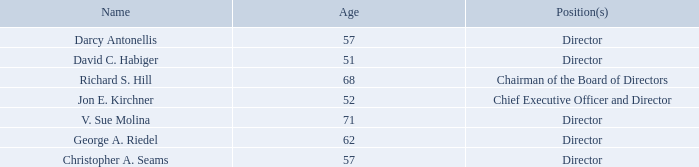Item 10. Directors, Executive Officers and Corporate Governance
Information About Our Board of Directors
Set forth below are the name, age and position of each member of our board of directors.
The following are biographical summaries of our board members.
Darcy Antonellis has served on the Board since December 2018. Since January 2014, Ms. Antonellis has been the Chief Executive Officer of Vubiquity, Inc., a wholly owned subsidiary of Amdocs Limited since February 22, 2018, the largest global provider of premium content services and technical solutions serving clients in 120 countries and in 80 languages. From June 1998 until December 2013, Ms. Antonellis held numerous positions at Warner Bros. Entertainment Inc., a Time Warner company, including President, Technical Operations and Chief Technology Officer. Ms. Antonellis has also served as a member of the Board of Directors of Cinemark Holdings, Inc. since July 7, 2015. Ms, Antonellis received a B.S. in electrical engineering from Temple University and an M.B.A. from Fordham University. The Board believes Ms. Antonellis brings her extensive expertise in executive management, operations and engineering and her in-depth understanding of content services, media and entertainment industry to her role as a member of the Board.
David C. Habiger has served on the Board since December 2016. Mr. Habiger currently serves as the Chief Executive Officer of JD Power, a privately held company. Mr. Habiger served as a director of DTS from March 2014 until its acquisition by the Company in December 2016. Mr. Habiger serves as a director of the Chicago Federal Reserve Board. He is on the SABOR (Systems Activities, Bank Operations and Risk) Committee and the Governance & HR Committee for the
Federal Reserve. Mr. Habiger served as the CEO at Textura Corporation, a soft
David C. Habiger has served on the Board since December 2016. Mr. Habiger currently serves as the Chief Executive Officer of JD Power, a privately held company. Mr. Habiger served as a director of DTS from March 2014 until its acquisition by the Company in December 2016. Mr. Habiger serves as a director of the Chicago Federal Reserve Board. He is on the SABOR (Systems Activities, Bank Operations and Risk) Committee and the Governance & HR Committee for the Federal Reserve. Mr. Habiger served as the CEO at Textura Corporation, a soft David C. Habiger has served on the Board since December 2016. Mr. Habiger currently serves as the Chief Executive Officer of JD Power, a privately held company. Mr. Habiger served as a director of DTS from March 2014 until its acquisition by the Company in December 2016. Mr. Habiger serves as a director of the Chicago Federal Reserve Board. He is on the SABOR (Systems Activities, Bank Operations and Risk) Committee and the Governance & HR Committee for the Federal Reserve. Mr. Habiger served as the CEO at Textura Corporation, a software company focused on construction management, from May 2015 until its sale to Oracle in June 2016. From May 2011 to August 2012, he served as the Chief Executive Officer of NDS Group Ltd., a provider of video software and content security solutions. Mr. Habiger worked with the founding members of Sonic Solutions (“Sonic”), a computer software company, from 1992 to 2011 and served as President and Chief Executive Officer of Sonic from 2005 to 2011. He serves as a director for Echo Global Logistics, Inc., GrubHub Inc., and Stamps.com Inc., and previously served as a director for Control4 Corporation, Enova International, Inc., Immersion Corporation, RealD Inc., Textura Corporation, DTS, and Sonic Solutions. He is a member of the National Association of Corporate Directors and is on the Advisory Board of the University of Chicago Center for Entrepreneurship. Mr. Habiger received a bachelor’s degree in business administration from St. Norbert College and an M.B.A. from the University of Chicago. The Board believes that Mr. Habiger brings extensive experience in the digital media and entertainment industries and his in-depth knowledge and understanding of the consumer electronics industry to his role as a member of the Board.
Richard S. Hill has served as a member of the Board since August 2012 and as Chairman of the Board since March 2013. Mr. Hill also served as the Company’s Interim Chief Executive Officer from April 15, 2013 until May 29, 2013. Mr. Hill previously served as the Chief Executive Officer and member of the board of directors of Novellus Systems Inc., until its acquisition by Lam Research Corporation in June 2012. During his nearly 20 years leading Novellus Systems, a designer, manufacturer, and marketer of semiconductor equipment used in fabricating integrated circuits, Mr. Hill grew annual revenues from approximately $100 million to over $1 billion. Presently, Mr. Hill is Chairman of Marvell Technology Group Ltd. (“Marvell”), a producer of storage, communications and consumer semiconductor products, and a member of its board of directors. Mr. Hill served as Interim Chief Executive Officer of Marvell from May 2016 until July 2016. Mr. Hill is a member of the boards of directors of Arrow Electronics, Inc., a global provider of products and services to industrial and commercial users of electronic components and enterprise computing, and Cabot Microelectronics Corporation, the leading global supplier of chemical mechanical planarization (CMP) slurries and a growing CMP pad supplier to the semiconductor industry. Mr. Hill previously served on the board of directors of Symantec Corporation, LSI Corporation, Planar Systems, Autodesk, Inc. and Yahoo Inc. Mr. Hill received a B.S. in Bioengineering from the University of Illinois in Chicago and an M.B.A. from Syracuse University. The Board believes that Mr. Hill brings extensive expertise in executive management and engineering for technology and defenserelated companies to his role as Chairman of the Board.
Jon E. Kirchner has served on the Board and as Chief Executive Officer since June 2017. Previously he was president of Xperi following the completion of the acquisition of DTS in December 2016. He served as DTS’s Chairman of the board of directors and Chief Executive Officer from 2010 to December 2016 and had been a member of DTS’s board of directors from 2002 to December 2016. From 2001 to 2010, he served as DTS’s Chief Executive Officer. Prior to his tenure as Chief Executive Officer, Mr. Kirchner served at DTS from 1993 to 2001 in a number of senior leadership roles including President, Chief Operating Officer and Chief Financial Officer. Prior to joining DTS, Mr. Kirchner worked for the consulting and audit groups at Price Waterhouse LLP (now PricewaterhouseCoopers LLP), an international accounting firm. In 2012, Mr. Kirchner received the Ernst & Young Technology Entrepreneur of the Year Award for Greater Los Angeles. In 2011, Mr. Kirchner was honored by the Producers Guild of America, receiving the “Digital 25: Leaders in Emerging Entertainment” award for being among the visionaries that have made significant contributions to the advancement of digital entertainment and storytelling. Mr. Kirchner currently serves on the board of directors of Free Stream Media Corporation (Samba TV), a leader in developing cross platform TV experiences for consumers and advertisers. Mr. Kirchner is a Certified Public Accountant and received a B.A. in Economics, cum laude, from Claremont McKenna College. The Board believes that Mr. Kirchner brings his experience in the senior management of public companies, including service as chairman, president, Chief Executive Officer, Chief Operating Officer and Chief Financial Officer, his extensive experience in the digital media and entertainment industries, as well as his knowledge of the Company as its Chief Executive Officer, to his role as a member of the Board.
V. Sue Molina has served on the Board since February 2018. Most recently she served on the Board of Directors of DTS from January 2008 until December 2016, and served as Chair of the Audit Committee and Nominating and Corporate Governance Committee. From November 1997 until her retirement in May 2004, Ms. Molina was a tax partner at Deloitte & Touche LLP, an international accounting firm, serving from 2000 until May 2004 as the national partner in charge of Deloitte’s Initiative for the Retention and Advancement of Women. Prior to that, she spent twenty years with Ernst & Young LLP, an international accounting firm, the last ten years as a partner. Ms. Molina has prior board experience serving on the Board of Directors, chair of the Compensation Committee and member of the Audit Committee of Sucampo Pharmaceuticals, Inc., and on the Board of Directors, chair of the Audit Committee and a member of the Compensation Committee of Royal Neighbors of America. She received a B.S.B.A. and a Masters of Accounting degree from the University of Arizona. The Board believes that Ms. Molina brings her extensive accounting and financial expertise, her experience in advising boards and her past service on boards of public companies, to her role as a member of the Board.
George A. Riedel has served on the Board since May 2013. He also has served on the board of Cerner Corporation, a leading supplier of health care information technology solutions and tech-enabled services, since May 2019. Since January 2018, Mr. Riedel has been a Senior Lecturer at Harvard Business School. Prior to that, he was the Chairman of the Board of Montreal-based Accedian Networks, where he had served as a director since 2010. Until January 2017, Mr. Riedel also served as Chairman and CEO of Cloudmark, Inc., a private network security company. Mr. Riedel joined the board at Cloudmark in June 2013, became Chairman in January 2014 and CEO in December 2014. Mr. Riedel also served on the board of directors of PeerApp from 2011 until 2014 and on the board of directors of Blade Network Technologies from 2009 until its sale to IBM in 2010. In March 2006, Mr. Riedel joined Nortel Networks Corporation, a publicly-traded, multinational, telecommunications equipment manufacturer (“Nortel”), as part of the turnaround team as the Chief Strategy Officer. His role changed after Nortel initiated creditor protection under the respective restructuring regimes of Canada under the Companies’ Creditors Arrangement Act, in the U.S. under the Bankruptcy Code, the United Kingdom under the Insolvency Act 1986, on January 14, 2009, and subsequently, Israel, to lead the sale/restructuring of various carrier and enterprise business units through a series of transactions to leading industry players such as Ericsson, Avaya and Ciena. Mr. Riedel led the efforts to create stand-alone business units, carve out the relevant P&L and balance sheet elements and assign patents to enable sales of the assets. In 2010, Mr. Riedel’s role changed to President of Business Units and CSO as he took leadership of the effort to monetize the remaining 6,500 patents and applications patents as well as manage the P&L for several business units that were held for sale. The 2011 patent sale led to an unprecedented transaction of $4.5 billion to a consortium of Apple, Ericsson, RIM, Microsoft and EMC. Prior to Nortel, Mr. Riedel was the Vice President of Strategy and Corporate Development of Juniper Networks, Inc., a publicly-traded designer, developer and manufacturer of networking products, from 2003 until 2006. Previously, Mr. Riedel was also a Director at McKinsey & Company, a global management consulting firm, where he spent 15 years serving clients in the telecom and technology sectors in Asia and North America on a range of strategy and growth issues. Mr. Riedel received a B.S. with Distinction in Mechanical Engineering from the University of Virginia and his M.B.A. from Harvard Business School. Mr. Riedel holds a Stanford Directors’ College certification based on completion of its corporate directors training. The Board believes that Mr. Riedel brings his experience from his direct involvement in the restructuring of Nortel, including the sale of Nortel’s patent portfolio for $4.5 billion, as well as his knowledge of the technology industry and leadership experience, to his role as a member of the Board.
Christopher A. Seams has served on the Board since March 2013. Mr. Seams served as the Chief Executive Officer and a director of Deca Technologies Inc., a subsidiary of Cypress Semiconductor Corporation, a global semiconductor company, from May 2013 until August 2016. Mr. Seams previously was an Executive Vice President of Sales & Marketing at Cypress Semiconductor Corporation, from July 2005 until June 2013. He previously served as an Executive Vice President of Worldwide Manufacturing & Research and Development of Cypress Semiconductor Corporation. Mr. Seams joined Cypress in 1990 and held a variety of positions in process and assembly technology research and development and manufacturing operations. Prior to joining Cypress in 1990, he worked as a process development Engineer or Manager for Advanced Micro Devices and Philips Research Laboratories. Mr. Seams currently serves as the Chairman of the Board of Directors of Onto Innovation Inc. (formerly Nanometrics Inc.). Mr. Seams is a senior member of IEEE, a member of NACD and ACCD, served on the Engineering Advisory Council for Texas A&M University and was a board member of Joint Venture Silicon Valley. Mr. Seams received a B.S. in Electrical Engineering from Texas A&M University and a M.S. in Electrical and Computer Engineering from the University of Texas at Austin. Mr. Seams has a Professional Certificate in Advanced Computer Security from Stanford University. Mr. Seams also holds a National Association of Corporate Directors certification which was awarded to him based on NACD training and examination standards. The Board believes that Mr. Seams brings extensive management, sales and marketing, and engineering experience in the semiconductor industry to his role as a member of the Board.
Who are the members of the board of directors? Darcy antonellis, david c. habiger, richard s. hill, jon e. kirchner, v. sue molina, george a. riedel, christopher a. seams. Who is the Chairman of the Board? Richard s. hill. What is the average age of the board members? (57+51+68+52+71+62+57)/7 
Answer: 59.71. Who is the oldest among all board members? 71 is the highest
Answer: v. sue molina. What is the proportion of years that David C. Habiger worked in Sonic Solutions throughout his whole life? (2011-1992)/51 
Answer: 0.37. Since when did Darcy Antonellis serve as a member of the Board of Directors? December 2018. 